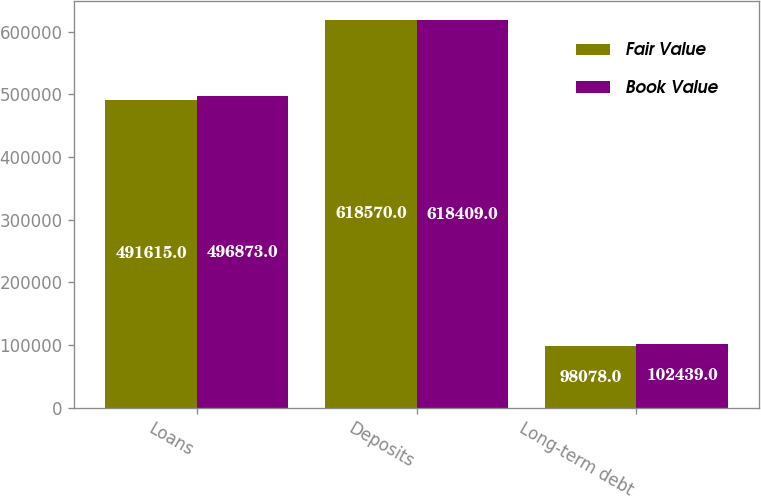<chart> <loc_0><loc_0><loc_500><loc_500><stacked_bar_chart><ecel><fcel>Loans<fcel>Deposits<fcel>Long-term debt<nl><fcel>Fair Value<fcel>491615<fcel>618570<fcel>98078<nl><fcel>Book Value<fcel>496873<fcel>618409<fcel>102439<nl></chart> 